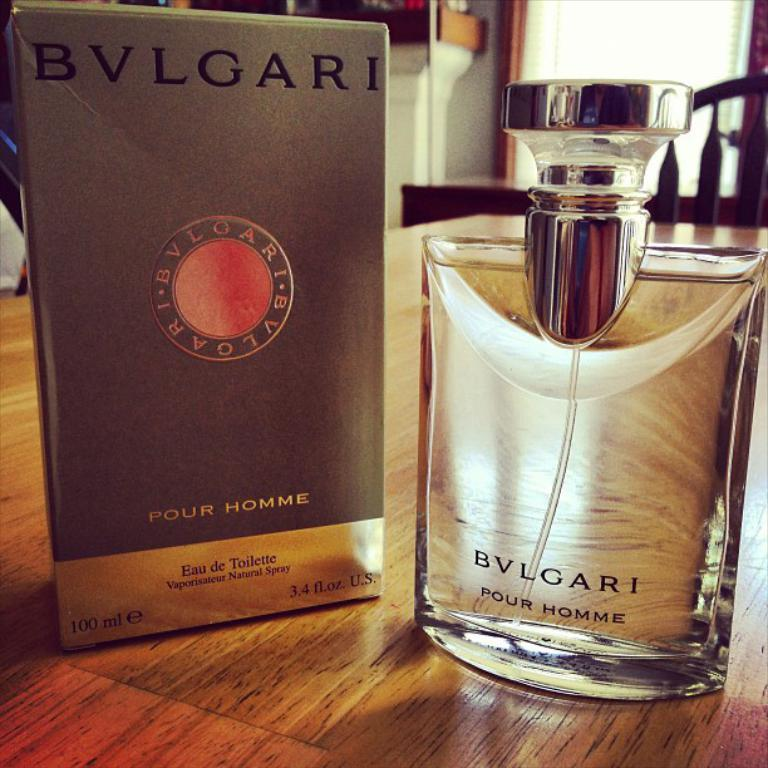<image>
Write a terse but informative summary of the picture. A fragrance produced by the brand of BVLGARI. 